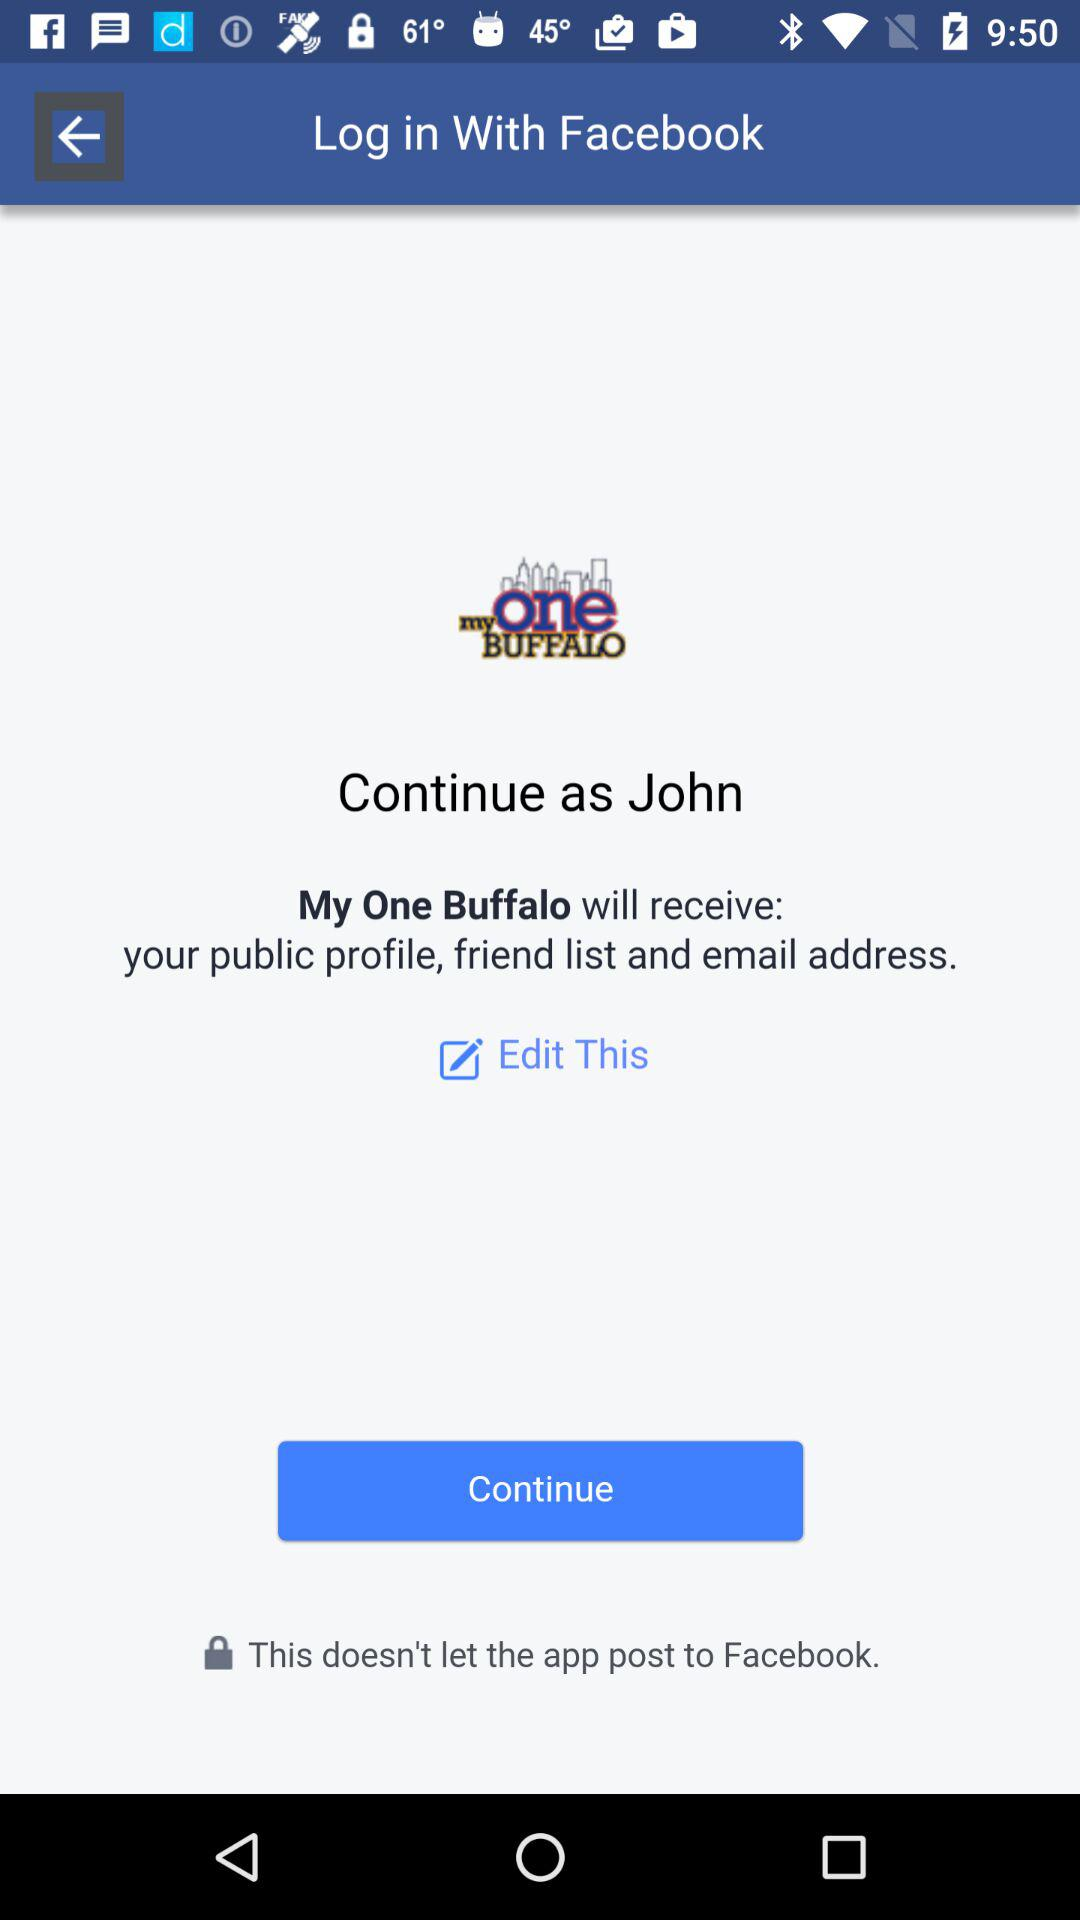What is the name of the user? The name of the user is John. 